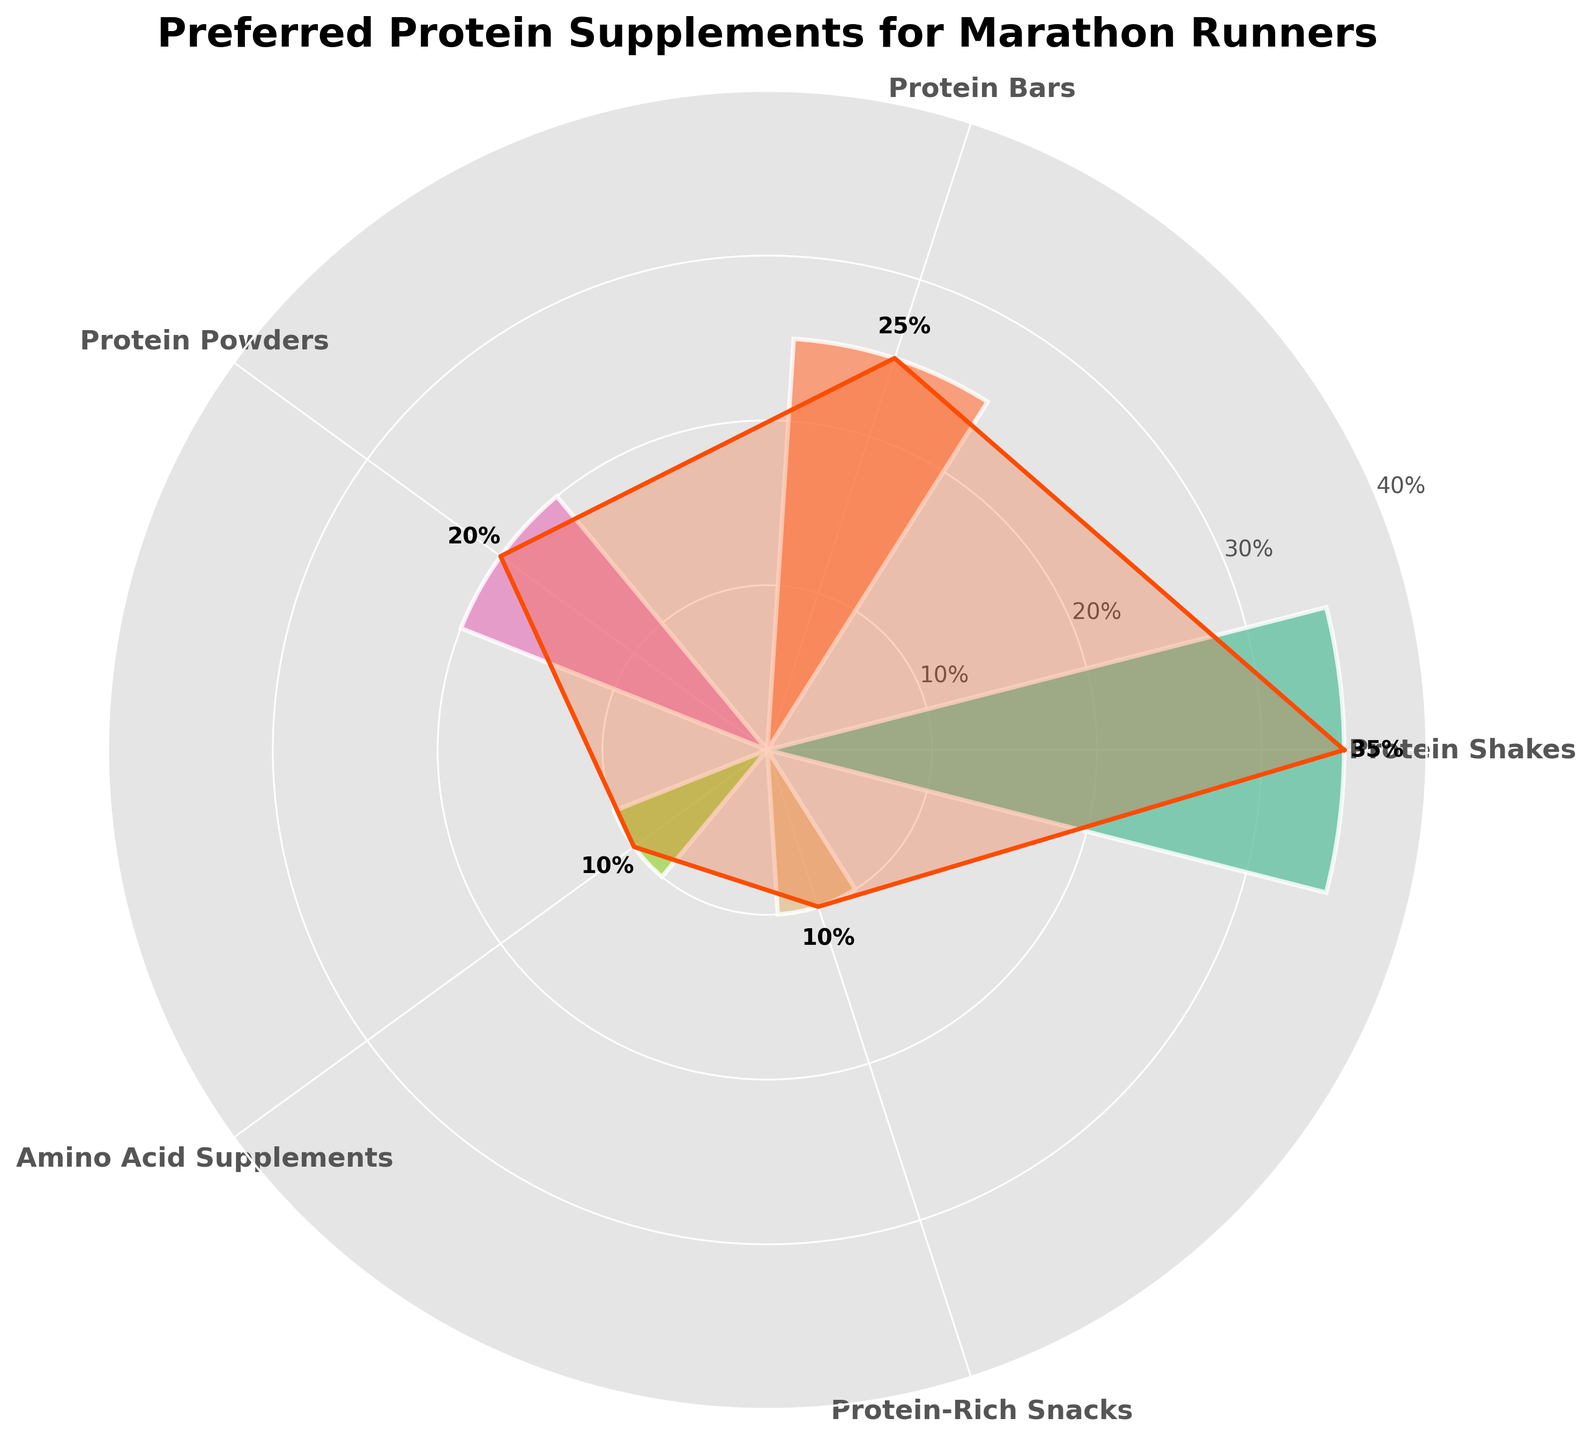What's the title of the chart? The title of the chart is usually displayed prominently at the top of the figure, formatted in a larger and bold font. In this case, the title is "Preferred Protein Supplements for Marathon Runners."
Answer: Preferred Protein Supplements for Marathon Runners How many different categories of protein supplements are displayed? Count the number of different labeled wedges on the rose chart. Here, there are five distinct categories.
Answer: 5 Which category has the highest percentage? The segment with the highest percentage will be the widest bar in the rose chart. According to the data, Protein Shakes have the highest percentage.
Answer: Protein Shakes What is the total percentage of Protein Powders and Amino Acid Supplements combined? Add the percentages of Protein Powders (20%) and Amino Acid Supplements (10%). 20% + 10% = 30%.
Answer: 30% What is the difference in percentage between Protein Shakes and Protein Bars? Subtract the percentage of Protein Bars (25%) from the percentage of Protein Shakes (35%). 35% - 25% = 10%.
Answer: 10% Which categories have the same percentage? Look for segments on the chart with the same width to identify categories with equal percentages. Protein-Rich Snacks and Amino Acid Supplements both have a percentage of 10%.
Answer: Protein-Rich Snacks and Amino Acid Supplements Which category takes up the smallest area in the chart and what is its percentage? Identify the narrowest wedge on the rose chart, which represents the smallest percentage. Both Protein-Rich Snacks and Amino Acid Supplements take up the smallest area with a percentage of 10%.
Answer: Protein-Rich Snacks and Amino Acid Supplements, 10% What percentage are Protein Bars lower than Protein Shakes by? Subtract the percentage of Protein Bars (25%) from Protein Shakes (35%) to find the difference. 35% - 25% = 10%, so Protein Bars are 10% lower than Protein Shakes.
Answer: 10% How much larger is the percentage of Protein Shakes compared to Protein Powders? Subtract the percentage of Protein Powders (20%) from Protein Shakes (35%) to find the difference. 35% - 20% = 15%.
Answer: 15% What is the average percentage of all the categories combined? Add all the percentages and divide by the number of categories. (35% + 25% + 20% + 10% + 10%) / 5 = 20%.
Answer: 20% 